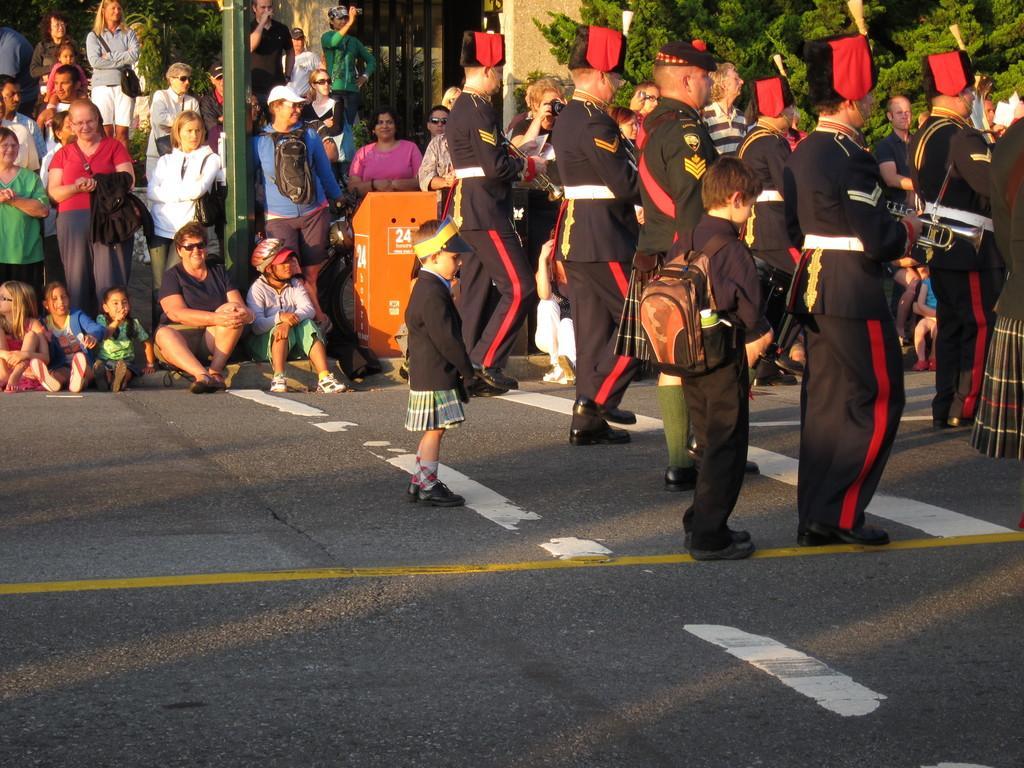In one or two sentences, can you explain what this image depicts? In this image there are people marching on a road, in the background there are people sitting on footpath and few are standing and there are trees. 